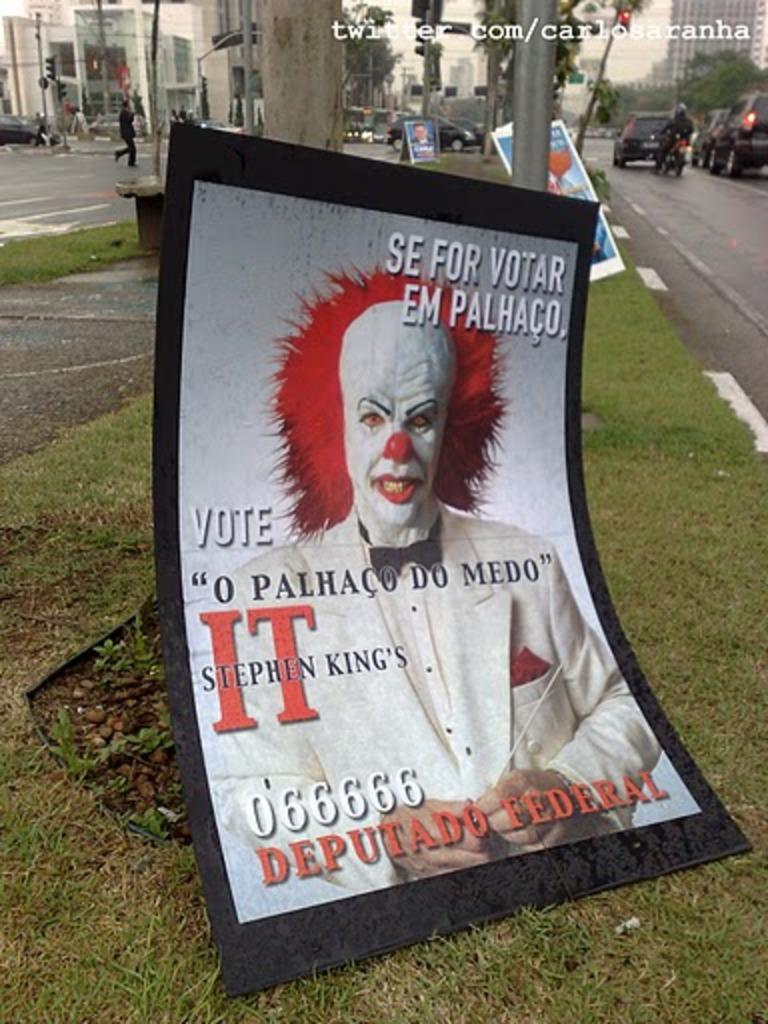Provide a one-sentence caption for the provided image. A political campaign poster tells people to vote and has a picture of a clown on it. 